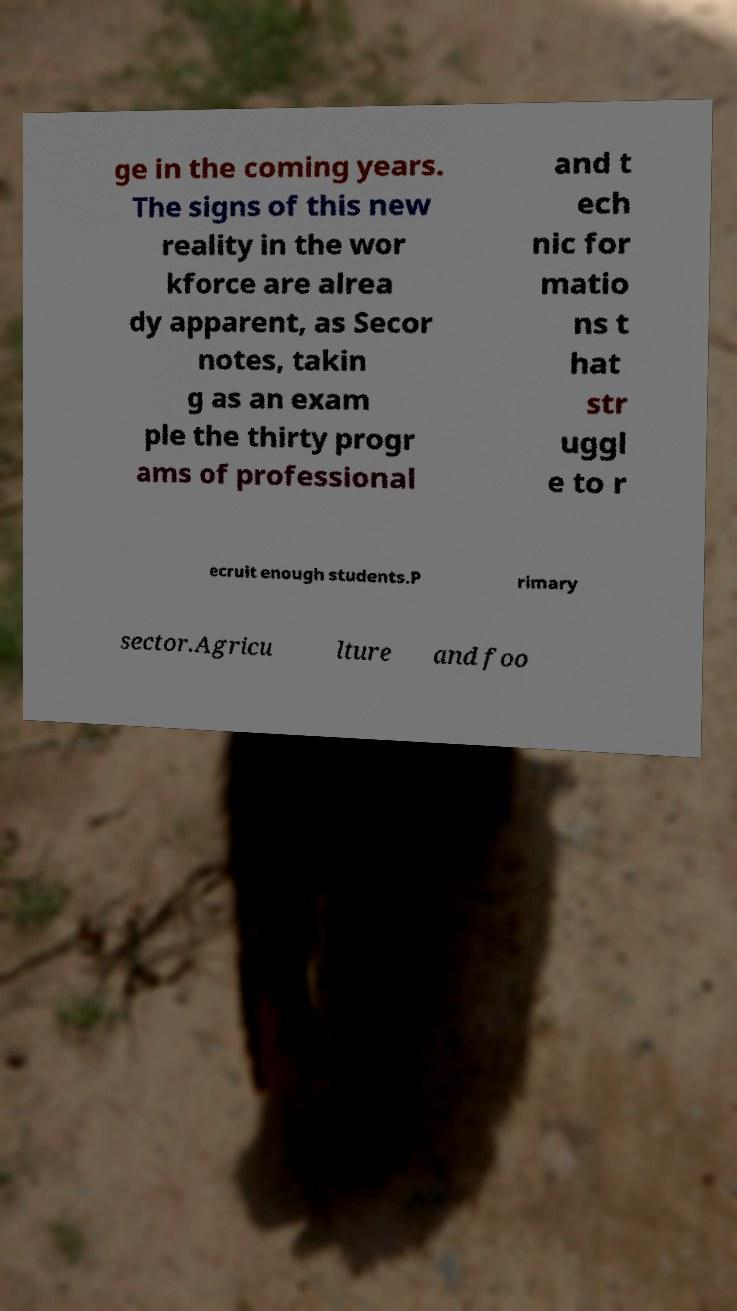What messages or text are displayed in this image? I need them in a readable, typed format. ge in the coming years. The signs of this new reality in the wor kforce are alrea dy apparent, as Secor notes, takin g as an exam ple the thirty progr ams of professional and t ech nic for matio ns t hat str uggl e to r ecruit enough students.P rimary sector.Agricu lture and foo 